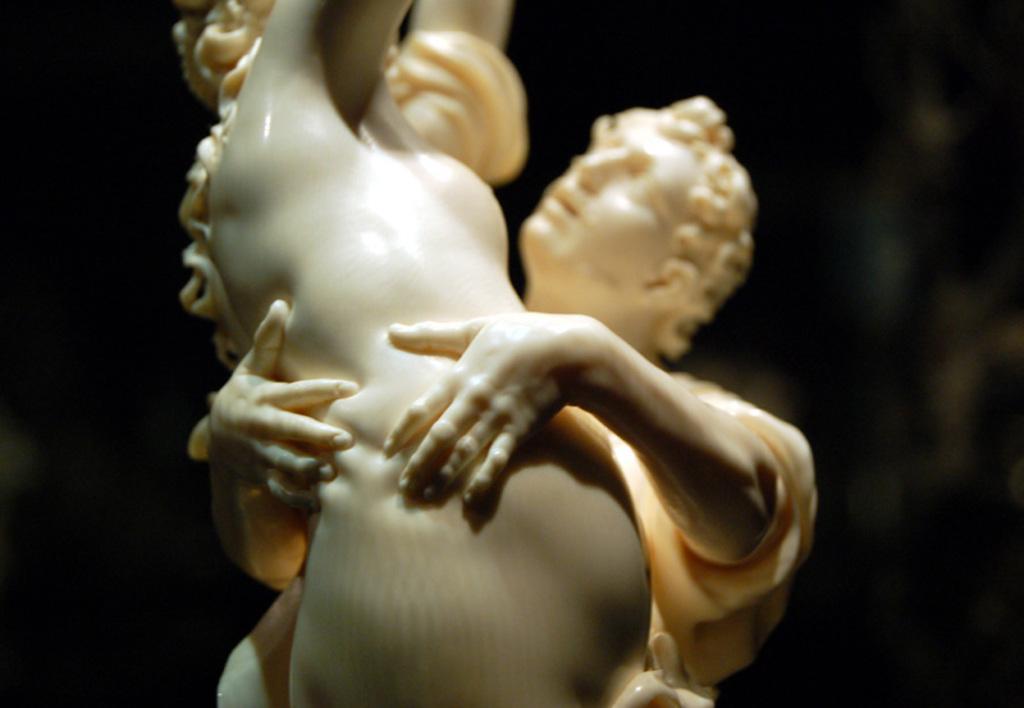How would you summarize this image in a sentence or two? In this image I can see a sculpture of two persons. The background is in black color. 